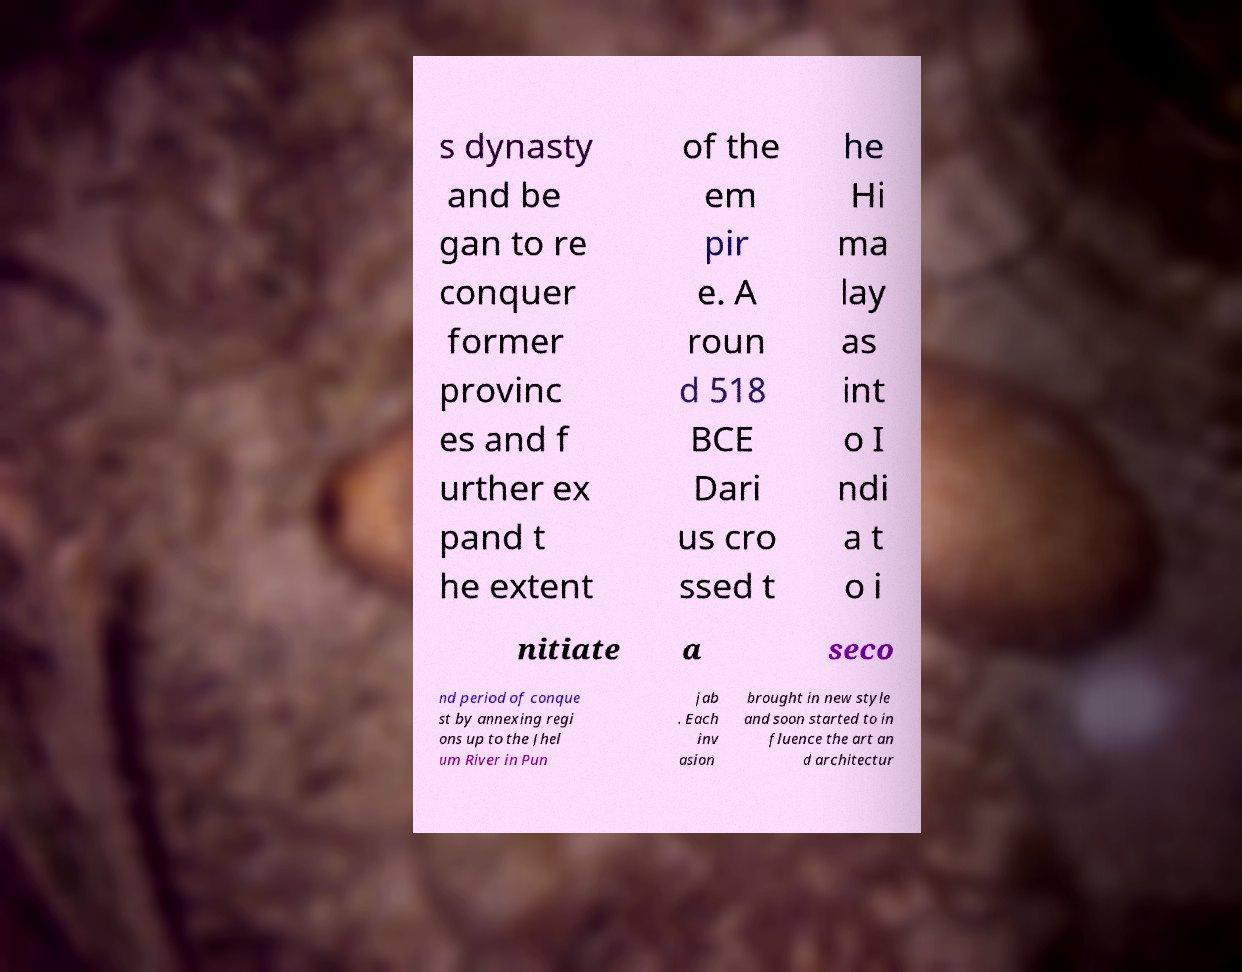There's text embedded in this image that I need extracted. Can you transcribe it verbatim? s dynasty and be gan to re conquer former provinc es and f urther ex pand t he extent of the em pir e. A roun d 518 BCE Dari us cro ssed t he Hi ma lay as int o I ndi a t o i nitiate a seco nd period of conque st by annexing regi ons up to the Jhel um River in Pun jab . Each inv asion brought in new style and soon started to in fluence the art an d architectur 